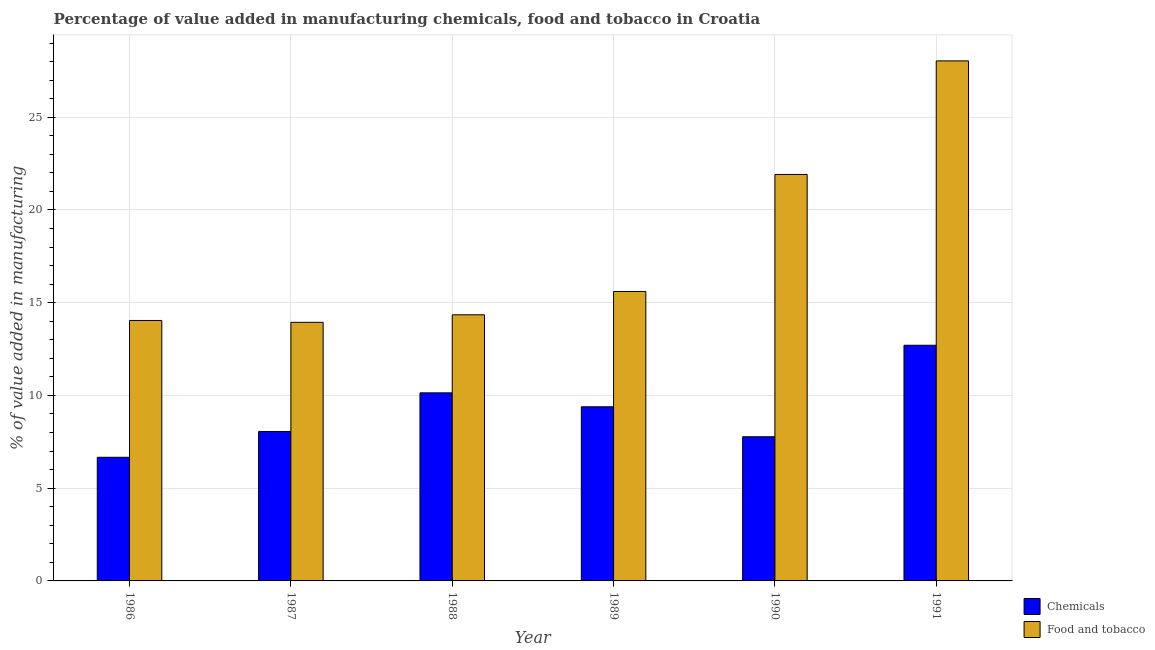How many different coloured bars are there?
Your answer should be very brief. 2. How many groups of bars are there?
Provide a succinct answer. 6. Are the number of bars per tick equal to the number of legend labels?
Your answer should be compact. Yes. What is the value added by manufacturing food and tobacco in 1988?
Your answer should be compact. 14.35. Across all years, what is the maximum value added by manufacturing food and tobacco?
Your answer should be compact. 28.04. Across all years, what is the minimum value added by  manufacturing chemicals?
Keep it short and to the point. 6.67. What is the total value added by  manufacturing chemicals in the graph?
Your answer should be compact. 54.72. What is the difference between the value added by manufacturing food and tobacco in 1990 and that in 1991?
Your answer should be compact. -6.12. What is the difference between the value added by  manufacturing chemicals in 1986 and the value added by manufacturing food and tobacco in 1988?
Your answer should be compact. -3.47. What is the average value added by  manufacturing chemicals per year?
Offer a terse response. 9.12. In how many years, is the value added by manufacturing food and tobacco greater than 20 %?
Offer a very short reply. 2. What is the ratio of the value added by  manufacturing chemicals in 1989 to that in 1991?
Provide a succinct answer. 0.74. Is the difference between the value added by manufacturing food and tobacco in 1986 and 1989 greater than the difference between the value added by  manufacturing chemicals in 1986 and 1989?
Make the answer very short. No. What is the difference between the highest and the second highest value added by manufacturing food and tobacco?
Your answer should be compact. 6.12. What is the difference between the highest and the lowest value added by manufacturing food and tobacco?
Offer a terse response. 14.1. In how many years, is the value added by  manufacturing chemicals greater than the average value added by  manufacturing chemicals taken over all years?
Your answer should be very brief. 3. What does the 2nd bar from the left in 1988 represents?
Offer a very short reply. Food and tobacco. What does the 2nd bar from the right in 1990 represents?
Ensure brevity in your answer.  Chemicals. How many bars are there?
Your answer should be very brief. 12. What is the difference between two consecutive major ticks on the Y-axis?
Ensure brevity in your answer.  5. How many legend labels are there?
Your answer should be compact. 2. How are the legend labels stacked?
Your response must be concise. Vertical. What is the title of the graph?
Your response must be concise. Percentage of value added in manufacturing chemicals, food and tobacco in Croatia. What is the label or title of the Y-axis?
Your response must be concise. % of value added in manufacturing. What is the % of value added in manufacturing in Chemicals in 1986?
Your response must be concise. 6.67. What is the % of value added in manufacturing in Food and tobacco in 1986?
Provide a short and direct response. 14.04. What is the % of value added in manufacturing in Chemicals in 1987?
Your answer should be compact. 8.06. What is the % of value added in manufacturing in Food and tobacco in 1987?
Your answer should be very brief. 13.94. What is the % of value added in manufacturing of Chemicals in 1988?
Your response must be concise. 10.14. What is the % of value added in manufacturing in Food and tobacco in 1988?
Your answer should be compact. 14.35. What is the % of value added in manufacturing in Chemicals in 1989?
Keep it short and to the point. 9.39. What is the % of value added in manufacturing in Food and tobacco in 1989?
Your response must be concise. 15.6. What is the % of value added in manufacturing in Chemicals in 1990?
Offer a terse response. 7.77. What is the % of value added in manufacturing of Food and tobacco in 1990?
Give a very brief answer. 21.91. What is the % of value added in manufacturing in Chemicals in 1991?
Offer a very short reply. 12.7. What is the % of value added in manufacturing of Food and tobacco in 1991?
Give a very brief answer. 28.04. Across all years, what is the maximum % of value added in manufacturing of Chemicals?
Keep it short and to the point. 12.7. Across all years, what is the maximum % of value added in manufacturing in Food and tobacco?
Give a very brief answer. 28.04. Across all years, what is the minimum % of value added in manufacturing of Chemicals?
Keep it short and to the point. 6.67. Across all years, what is the minimum % of value added in manufacturing in Food and tobacco?
Provide a short and direct response. 13.94. What is the total % of value added in manufacturing in Chemicals in the graph?
Ensure brevity in your answer.  54.72. What is the total % of value added in manufacturing of Food and tobacco in the graph?
Give a very brief answer. 107.88. What is the difference between the % of value added in manufacturing in Chemicals in 1986 and that in 1987?
Keep it short and to the point. -1.39. What is the difference between the % of value added in manufacturing in Food and tobacco in 1986 and that in 1987?
Make the answer very short. 0.1. What is the difference between the % of value added in manufacturing in Chemicals in 1986 and that in 1988?
Make the answer very short. -3.47. What is the difference between the % of value added in manufacturing in Food and tobacco in 1986 and that in 1988?
Make the answer very short. -0.31. What is the difference between the % of value added in manufacturing of Chemicals in 1986 and that in 1989?
Your answer should be very brief. -2.72. What is the difference between the % of value added in manufacturing in Food and tobacco in 1986 and that in 1989?
Offer a very short reply. -1.56. What is the difference between the % of value added in manufacturing of Chemicals in 1986 and that in 1990?
Your response must be concise. -1.11. What is the difference between the % of value added in manufacturing of Food and tobacco in 1986 and that in 1990?
Your answer should be very brief. -7.87. What is the difference between the % of value added in manufacturing of Chemicals in 1986 and that in 1991?
Provide a succinct answer. -6.04. What is the difference between the % of value added in manufacturing of Food and tobacco in 1986 and that in 1991?
Provide a succinct answer. -13.99. What is the difference between the % of value added in manufacturing of Chemicals in 1987 and that in 1988?
Your answer should be compact. -2.08. What is the difference between the % of value added in manufacturing in Food and tobacco in 1987 and that in 1988?
Offer a very short reply. -0.41. What is the difference between the % of value added in manufacturing in Chemicals in 1987 and that in 1989?
Offer a very short reply. -1.33. What is the difference between the % of value added in manufacturing in Food and tobacco in 1987 and that in 1989?
Ensure brevity in your answer.  -1.66. What is the difference between the % of value added in manufacturing of Chemicals in 1987 and that in 1990?
Your answer should be compact. 0.29. What is the difference between the % of value added in manufacturing of Food and tobacco in 1987 and that in 1990?
Your answer should be compact. -7.97. What is the difference between the % of value added in manufacturing in Chemicals in 1987 and that in 1991?
Provide a succinct answer. -4.65. What is the difference between the % of value added in manufacturing of Food and tobacco in 1987 and that in 1991?
Offer a terse response. -14.1. What is the difference between the % of value added in manufacturing of Chemicals in 1988 and that in 1989?
Keep it short and to the point. 0.75. What is the difference between the % of value added in manufacturing in Food and tobacco in 1988 and that in 1989?
Give a very brief answer. -1.26. What is the difference between the % of value added in manufacturing in Chemicals in 1988 and that in 1990?
Keep it short and to the point. 2.37. What is the difference between the % of value added in manufacturing of Food and tobacco in 1988 and that in 1990?
Offer a very short reply. -7.57. What is the difference between the % of value added in manufacturing in Chemicals in 1988 and that in 1991?
Provide a short and direct response. -2.57. What is the difference between the % of value added in manufacturing in Food and tobacco in 1988 and that in 1991?
Offer a very short reply. -13.69. What is the difference between the % of value added in manufacturing in Chemicals in 1989 and that in 1990?
Provide a short and direct response. 1.62. What is the difference between the % of value added in manufacturing in Food and tobacco in 1989 and that in 1990?
Offer a terse response. -6.31. What is the difference between the % of value added in manufacturing in Chemicals in 1989 and that in 1991?
Ensure brevity in your answer.  -3.32. What is the difference between the % of value added in manufacturing in Food and tobacco in 1989 and that in 1991?
Give a very brief answer. -12.43. What is the difference between the % of value added in manufacturing in Chemicals in 1990 and that in 1991?
Ensure brevity in your answer.  -4.93. What is the difference between the % of value added in manufacturing in Food and tobacco in 1990 and that in 1991?
Ensure brevity in your answer.  -6.12. What is the difference between the % of value added in manufacturing in Chemicals in 1986 and the % of value added in manufacturing in Food and tobacco in 1987?
Provide a succinct answer. -7.28. What is the difference between the % of value added in manufacturing of Chemicals in 1986 and the % of value added in manufacturing of Food and tobacco in 1988?
Provide a short and direct response. -7.68. What is the difference between the % of value added in manufacturing in Chemicals in 1986 and the % of value added in manufacturing in Food and tobacco in 1989?
Ensure brevity in your answer.  -8.94. What is the difference between the % of value added in manufacturing in Chemicals in 1986 and the % of value added in manufacturing in Food and tobacco in 1990?
Keep it short and to the point. -15.25. What is the difference between the % of value added in manufacturing in Chemicals in 1986 and the % of value added in manufacturing in Food and tobacco in 1991?
Ensure brevity in your answer.  -21.37. What is the difference between the % of value added in manufacturing in Chemicals in 1987 and the % of value added in manufacturing in Food and tobacco in 1988?
Offer a terse response. -6.29. What is the difference between the % of value added in manufacturing in Chemicals in 1987 and the % of value added in manufacturing in Food and tobacco in 1989?
Provide a short and direct response. -7.55. What is the difference between the % of value added in manufacturing in Chemicals in 1987 and the % of value added in manufacturing in Food and tobacco in 1990?
Provide a short and direct response. -13.86. What is the difference between the % of value added in manufacturing of Chemicals in 1987 and the % of value added in manufacturing of Food and tobacco in 1991?
Your answer should be compact. -19.98. What is the difference between the % of value added in manufacturing of Chemicals in 1988 and the % of value added in manufacturing of Food and tobacco in 1989?
Provide a succinct answer. -5.47. What is the difference between the % of value added in manufacturing in Chemicals in 1988 and the % of value added in manufacturing in Food and tobacco in 1990?
Provide a succinct answer. -11.77. What is the difference between the % of value added in manufacturing in Chemicals in 1988 and the % of value added in manufacturing in Food and tobacco in 1991?
Your answer should be compact. -17.9. What is the difference between the % of value added in manufacturing in Chemicals in 1989 and the % of value added in manufacturing in Food and tobacco in 1990?
Offer a very short reply. -12.53. What is the difference between the % of value added in manufacturing in Chemicals in 1989 and the % of value added in manufacturing in Food and tobacco in 1991?
Your answer should be very brief. -18.65. What is the difference between the % of value added in manufacturing of Chemicals in 1990 and the % of value added in manufacturing of Food and tobacco in 1991?
Offer a very short reply. -20.26. What is the average % of value added in manufacturing of Chemicals per year?
Give a very brief answer. 9.12. What is the average % of value added in manufacturing in Food and tobacco per year?
Keep it short and to the point. 17.98. In the year 1986, what is the difference between the % of value added in manufacturing of Chemicals and % of value added in manufacturing of Food and tobacco?
Your response must be concise. -7.38. In the year 1987, what is the difference between the % of value added in manufacturing in Chemicals and % of value added in manufacturing in Food and tobacco?
Your answer should be very brief. -5.88. In the year 1988, what is the difference between the % of value added in manufacturing in Chemicals and % of value added in manufacturing in Food and tobacco?
Keep it short and to the point. -4.21. In the year 1989, what is the difference between the % of value added in manufacturing in Chemicals and % of value added in manufacturing in Food and tobacco?
Provide a short and direct response. -6.22. In the year 1990, what is the difference between the % of value added in manufacturing of Chemicals and % of value added in manufacturing of Food and tobacco?
Keep it short and to the point. -14.14. In the year 1991, what is the difference between the % of value added in manufacturing of Chemicals and % of value added in manufacturing of Food and tobacco?
Provide a succinct answer. -15.33. What is the ratio of the % of value added in manufacturing in Chemicals in 1986 to that in 1987?
Give a very brief answer. 0.83. What is the ratio of the % of value added in manufacturing in Chemicals in 1986 to that in 1988?
Your answer should be compact. 0.66. What is the ratio of the % of value added in manufacturing of Food and tobacco in 1986 to that in 1988?
Give a very brief answer. 0.98. What is the ratio of the % of value added in manufacturing in Chemicals in 1986 to that in 1989?
Keep it short and to the point. 0.71. What is the ratio of the % of value added in manufacturing in Food and tobacco in 1986 to that in 1989?
Give a very brief answer. 0.9. What is the ratio of the % of value added in manufacturing in Chemicals in 1986 to that in 1990?
Provide a succinct answer. 0.86. What is the ratio of the % of value added in manufacturing of Food and tobacco in 1986 to that in 1990?
Your answer should be compact. 0.64. What is the ratio of the % of value added in manufacturing in Chemicals in 1986 to that in 1991?
Give a very brief answer. 0.52. What is the ratio of the % of value added in manufacturing of Food and tobacco in 1986 to that in 1991?
Give a very brief answer. 0.5. What is the ratio of the % of value added in manufacturing of Chemicals in 1987 to that in 1988?
Your answer should be very brief. 0.79. What is the ratio of the % of value added in manufacturing of Food and tobacco in 1987 to that in 1988?
Provide a short and direct response. 0.97. What is the ratio of the % of value added in manufacturing in Chemicals in 1987 to that in 1989?
Your answer should be compact. 0.86. What is the ratio of the % of value added in manufacturing of Food and tobacco in 1987 to that in 1989?
Provide a short and direct response. 0.89. What is the ratio of the % of value added in manufacturing in Chemicals in 1987 to that in 1990?
Your answer should be very brief. 1.04. What is the ratio of the % of value added in manufacturing in Food and tobacco in 1987 to that in 1990?
Make the answer very short. 0.64. What is the ratio of the % of value added in manufacturing in Chemicals in 1987 to that in 1991?
Ensure brevity in your answer.  0.63. What is the ratio of the % of value added in manufacturing in Food and tobacco in 1987 to that in 1991?
Your response must be concise. 0.5. What is the ratio of the % of value added in manufacturing of Chemicals in 1988 to that in 1989?
Your response must be concise. 1.08. What is the ratio of the % of value added in manufacturing in Food and tobacco in 1988 to that in 1989?
Keep it short and to the point. 0.92. What is the ratio of the % of value added in manufacturing in Chemicals in 1988 to that in 1990?
Your answer should be very brief. 1.3. What is the ratio of the % of value added in manufacturing in Food and tobacco in 1988 to that in 1990?
Your answer should be very brief. 0.65. What is the ratio of the % of value added in manufacturing in Chemicals in 1988 to that in 1991?
Offer a terse response. 0.8. What is the ratio of the % of value added in manufacturing of Food and tobacco in 1988 to that in 1991?
Your response must be concise. 0.51. What is the ratio of the % of value added in manufacturing in Chemicals in 1989 to that in 1990?
Provide a succinct answer. 1.21. What is the ratio of the % of value added in manufacturing of Food and tobacco in 1989 to that in 1990?
Make the answer very short. 0.71. What is the ratio of the % of value added in manufacturing of Chemicals in 1989 to that in 1991?
Offer a very short reply. 0.74. What is the ratio of the % of value added in manufacturing of Food and tobacco in 1989 to that in 1991?
Keep it short and to the point. 0.56. What is the ratio of the % of value added in manufacturing in Chemicals in 1990 to that in 1991?
Give a very brief answer. 0.61. What is the ratio of the % of value added in manufacturing in Food and tobacco in 1990 to that in 1991?
Offer a terse response. 0.78. What is the difference between the highest and the second highest % of value added in manufacturing of Chemicals?
Ensure brevity in your answer.  2.57. What is the difference between the highest and the second highest % of value added in manufacturing in Food and tobacco?
Provide a succinct answer. 6.12. What is the difference between the highest and the lowest % of value added in manufacturing in Chemicals?
Make the answer very short. 6.04. What is the difference between the highest and the lowest % of value added in manufacturing in Food and tobacco?
Your answer should be compact. 14.1. 